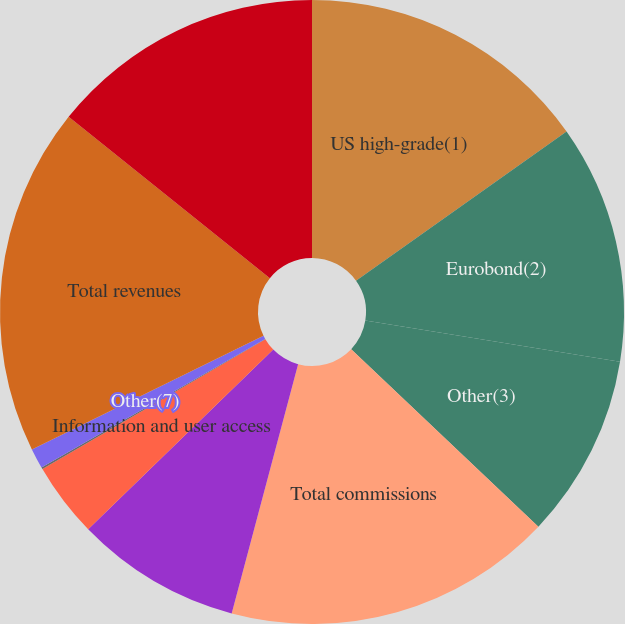Convert chart to OTSL. <chart><loc_0><loc_0><loc_500><loc_500><pie_chart><fcel>US high-grade(1)<fcel>Eurobond(2)<fcel>Other(3)<fcel>Total commissions<fcel>Technology products and<fcel>Information and user access<fcel>Interest income(6)<fcel>Other(7)<fcel>Total revenues<fcel>Employee compensation and<nl><fcel>15.19%<fcel>12.36%<fcel>9.53%<fcel>17.07%<fcel>8.59%<fcel>3.87%<fcel>0.1%<fcel>1.04%<fcel>18.02%<fcel>14.24%<nl></chart> 